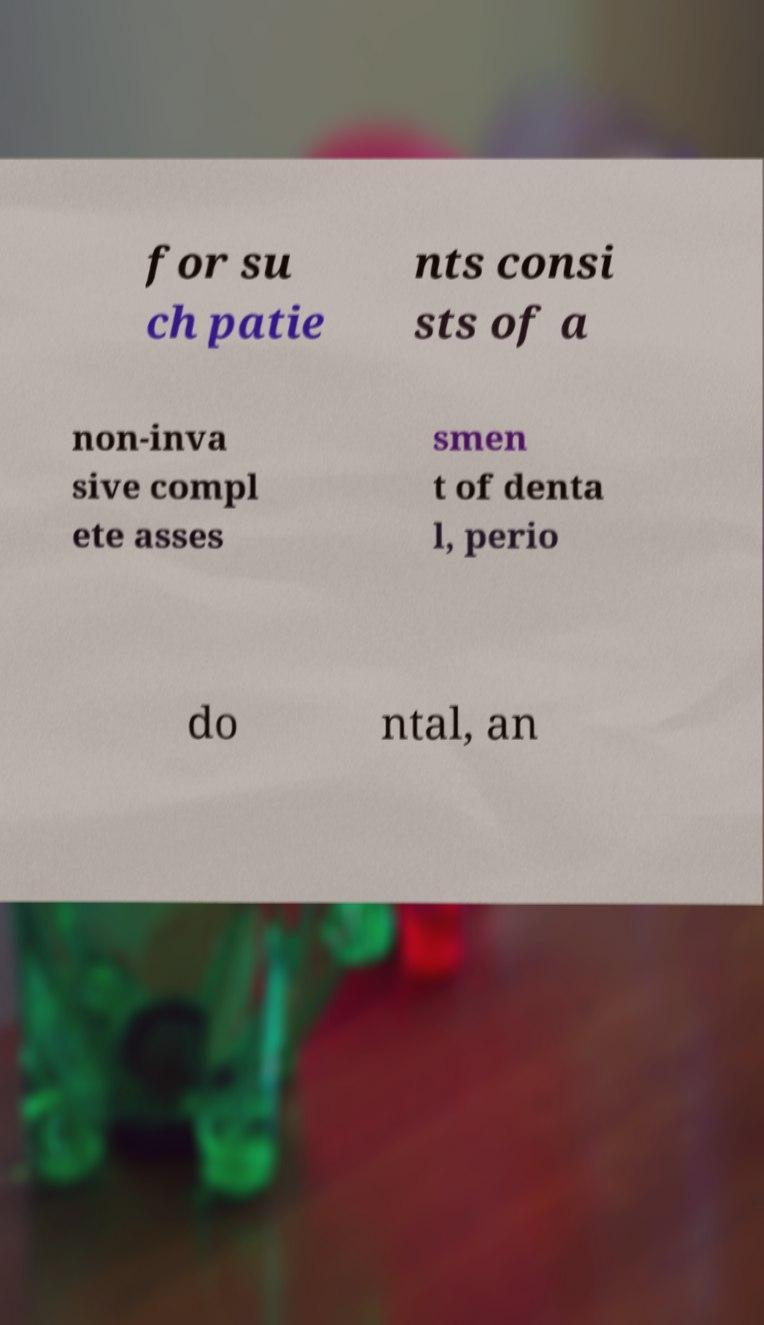I need the written content from this picture converted into text. Can you do that? for su ch patie nts consi sts of a non-inva sive compl ete asses smen t of denta l, perio do ntal, an 